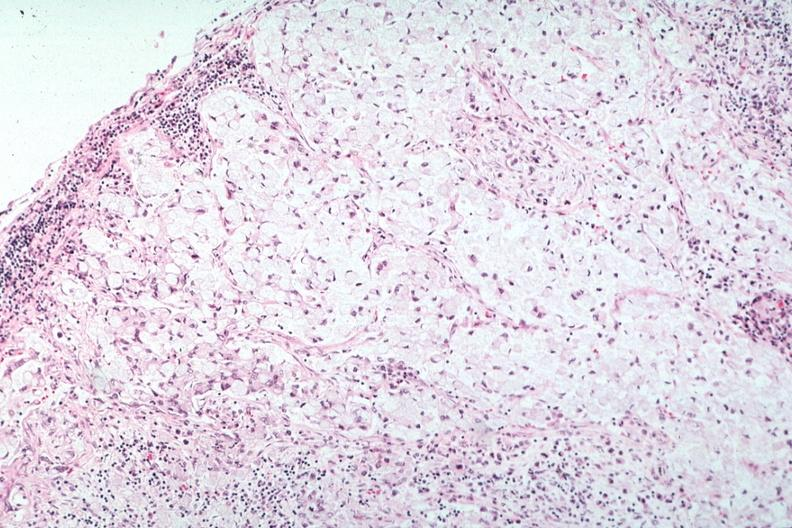what is present?
Answer the question using a single word or phrase. Lymph node 